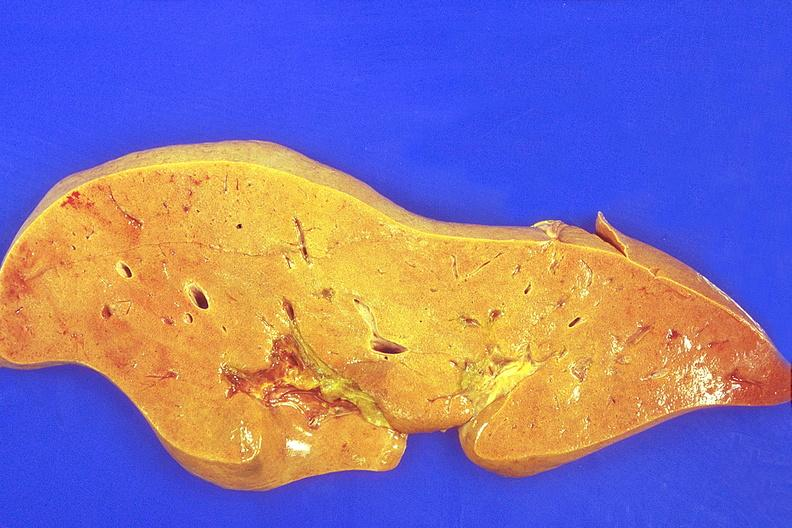what does this image show?
Answer the question using a single word or phrase. Liver 